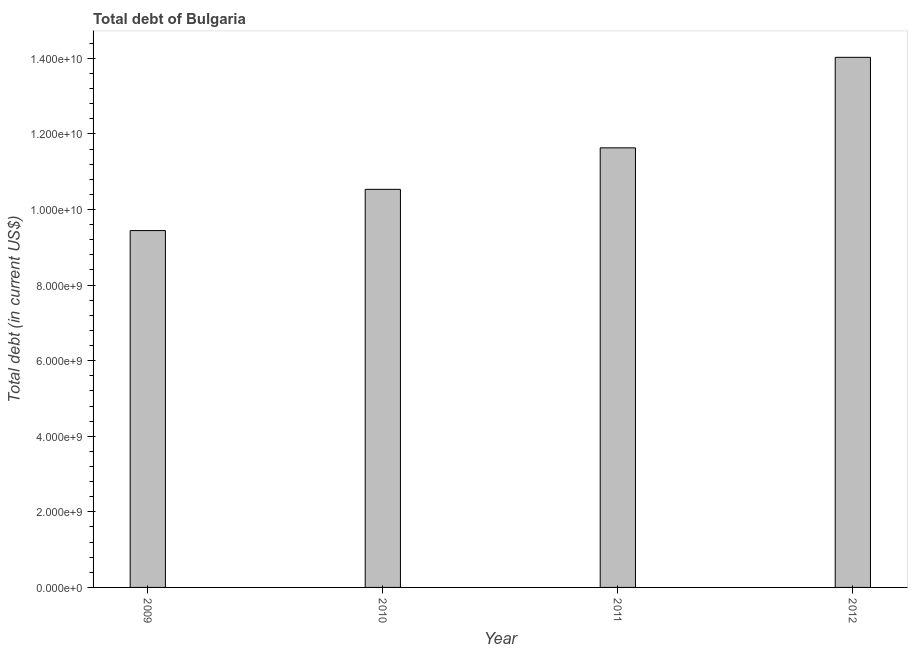What is the title of the graph?
Offer a terse response. Total debt of Bulgaria. What is the label or title of the Y-axis?
Your response must be concise. Total debt (in current US$). What is the total debt in 2012?
Provide a succinct answer. 1.40e+1. Across all years, what is the maximum total debt?
Your response must be concise. 1.40e+1. Across all years, what is the minimum total debt?
Provide a succinct answer. 9.44e+09. In which year was the total debt minimum?
Your response must be concise. 2009. What is the sum of the total debt?
Ensure brevity in your answer.  4.56e+1. What is the difference between the total debt in 2010 and 2011?
Provide a short and direct response. -1.10e+09. What is the average total debt per year?
Ensure brevity in your answer.  1.14e+1. What is the median total debt?
Provide a short and direct response. 1.11e+1. In how many years, is the total debt greater than 8000000000 US$?
Your answer should be very brief. 4. What is the ratio of the total debt in 2011 to that in 2012?
Ensure brevity in your answer.  0.83. Is the total debt in 2009 less than that in 2012?
Keep it short and to the point. Yes. Is the difference between the total debt in 2011 and 2012 greater than the difference between any two years?
Offer a very short reply. No. What is the difference between the highest and the second highest total debt?
Your response must be concise. 2.40e+09. What is the difference between the highest and the lowest total debt?
Keep it short and to the point. 4.58e+09. What is the difference between two consecutive major ticks on the Y-axis?
Make the answer very short. 2.00e+09. What is the Total debt (in current US$) of 2009?
Your answer should be very brief. 9.44e+09. What is the Total debt (in current US$) of 2010?
Your response must be concise. 1.05e+1. What is the Total debt (in current US$) in 2011?
Keep it short and to the point. 1.16e+1. What is the Total debt (in current US$) in 2012?
Keep it short and to the point. 1.40e+1. What is the difference between the Total debt (in current US$) in 2009 and 2010?
Provide a succinct answer. -1.09e+09. What is the difference between the Total debt (in current US$) in 2009 and 2011?
Keep it short and to the point. -2.19e+09. What is the difference between the Total debt (in current US$) in 2009 and 2012?
Provide a short and direct response. -4.58e+09. What is the difference between the Total debt (in current US$) in 2010 and 2011?
Ensure brevity in your answer.  -1.10e+09. What is the difference between the Total debt (in current US$) in 2010 and 2012?
Keep it short and to the point. -3.49e+09. What is the difference between the Total debt (in current US$) in 2011 and 2012?
Offer a very short reply. -2.40e+09. What is the ratio of the Total debt (in current US$) in 2009 to that in 2010?
Your response must be concise. 0.9. What is the ratio of the Total debt (in current US$) in 2009 to that in 2011?
Keep it short and to the point. 0.81. What is the ratio of the Total debt (in current US$) in 2009 to that in 2012?
Offer a very short reply. 0.67. What is the ratio of the Total debt (in current US$) in 2010 to that in 2011?
Your answer should be compact. 0.91. What is the ratio of the Total debt (in current US$) in 2010 to that in 2012?
Offer a very short reply. 0.75. What is the ratio of the Total debt (in current US$) in 2011 to that in 2012?
Offer a terse response. 0.83. 